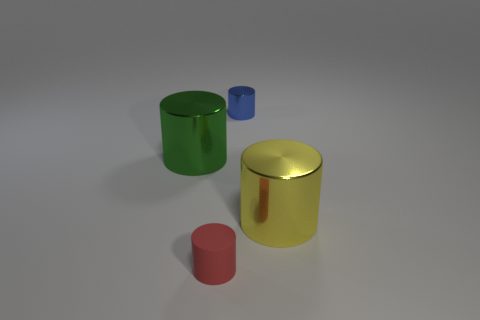What shape is the big thing that is in front of the metal cylinder on the left side of the thing that is behind the big green cylinder?
Make the answer very short. Cylinder. What number of other objects are the same shape as the green thing?
Keep it short and to the point. 3. How many matte things are either blue cylinders or small red balls?
Make the answer very short. 0. There is a big cylinder that is to the right of the small object that is in front of the large green metal thing; what is it made of?
Ensure brevity in your answer.  Metal. Are there more large green cylinders in front of the yellow shiny cylinder than red rubber cylinders?
Offer a very short reply. No. Is there a big yellow cylinder that has the same material as the green thing?
Provide a succinct answer. Yes. Is the shape of the small thing to the left of the tiny metallic thing the same as  the big yellow shiny thing?
Make the answer very short. Yes. What number of large cylinders are left of the large metallic cylinder right of the small cylinder that is behind the big green shiny thing?
Offer a terse response. 1. Is the number of small blue shiny cylinders that are in front of the tiny matte object less than the number of big green shiny cylinders that are right of the tiny blue metal cylinder?
Make the answer very short. No. There is another tiny metallic thing that is the same shape as the red object; what color is it?
Provide a succinct answer. Blue. 